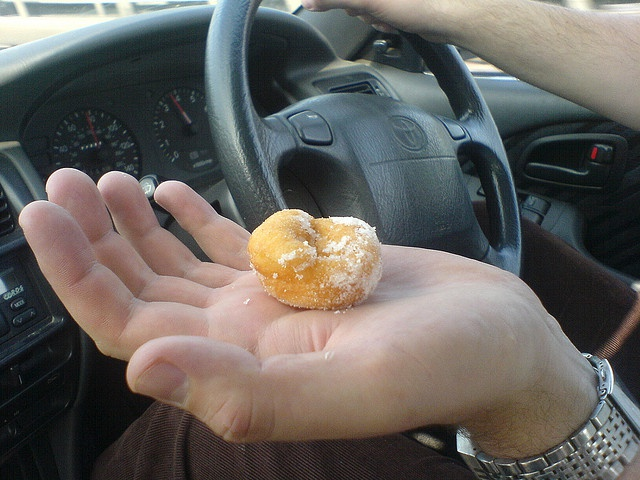Describe the objects in this image and their specific colors. I can see people in lightgray, darkgray, and gray tones and donut in lightgray, tan, and ivory tones in this image. 